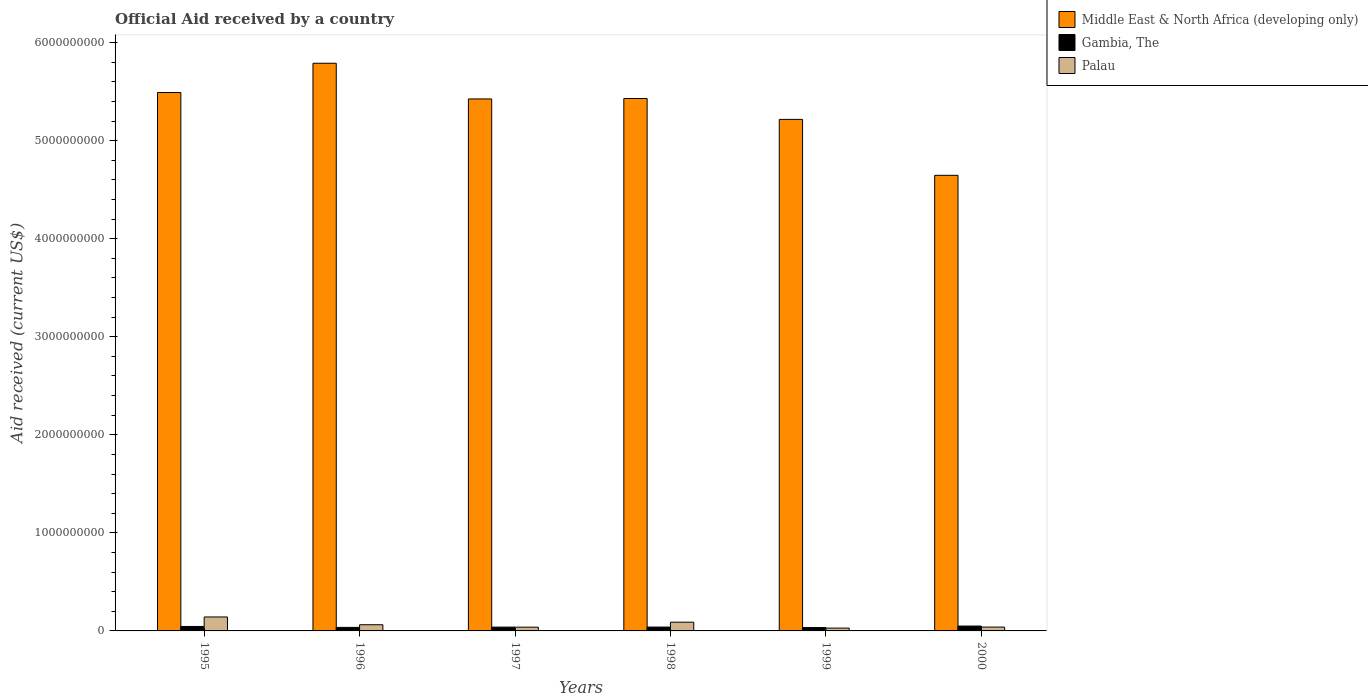Are the number of bars per tick equal to the number of legend labels?
Keep it short and to the point. Yes. What is the net official aid received in Gambia, The in 1997?
Provide a succinct answer. 3.88e+07. Across all years, what is the maximum net official aid received in Palau?
Provide a succinct answer. 1.42e+08. Across all years, what is the minimum net official aid received in Middle East & North Africa (developing only)?
Offer a very short reply. 4.65e+09. In which year was the net official aid received in Palau minimum?
Offer a very short reply. 1999. What is the total net official aid received in Middle East & North Africa (developing only) in the graph?
Keep it short and to the point. 3.20e+1. What is the difference between the net official aid received in Palau in 1996 and that in 2000?
Keep it short and to the point. 2.39e+07. What is the difference between the net official aid received in Palau in 1997 and the net official aid received in Gambia, The in 1995?
Ensure brevity in your answer.  -7.05e+06. What is the average net official aid received in Middle East & North Africa (developing only) per year?
Ensure brevity in your answer.  5.33e+09. In the year 1999, what is the difference between the net official aid received in Palau and net official aid received in Middle East & North Africa (developing only)?
Offer a terse response. -5.19e+09. What is the ratio of the net official aid received in Gambia, The in 1995 to that in 1998?
Your answer should be very brief. 1.16. Is the net official aid received in Palau in 1996 less than that in 1999?
Provide a short and direct response. No. What is the difference between the highest and the second highest net official aid received in Palau?
Make the answer very short. 5.32e+07. What is the difference between the highest and the lowest net official aid received in Gambia, The?
Keep it short and to the point. 1.54e+07. In how many years, is the net official aid received in Gambia, The greater than the average net official aid received in Gambia, The taken over all years?
Provide a succinct answer. 2. What does the 1st bar from the left in 1995 represents?
Offer a very short reply. Middle East & North Africa (developing only). What does the 1st bar from the right in 1998 represents?
Your answer should be very brief. Palau. How many bars are there?
Your answer should be very brief. 18. How many years are there in the graph?
Your answer should be very brief. 6. Are the values on the major ticks of Y-axis written in scientific E-notation?
Offer a very short reply. No. Does the graph contain any zero values?
Give a very brief answer. No. Does the graph contain grids?
Your response must be concise. No. Where does the legend appear in the graph?
Your response must be concise. Top right. How many legend labels are there?
Make the answer very short. 3. How are the legend labels stacked?
Keep it short and to the point. Vertical. What is the title of the graph?
Give a very brief answer. Official Aid received by a country. Does "Canada" appear as one of the legend labels in the graph?
Keep it short and to the point. No. What is the label or title of the X-axis?
Keep it short and to the point. Years. What is the label or title of the Y-axis?
Your answer should be compact. Aid received (current US$). What is the Aid received (current US$) of Middle East & North Africa (developing only) in 1995?
Offer a terse response. 5.49e+09. What is the Aid received (current US$) of Gambia, The in 1995?
Provide a short and direct response. 4.54e+07. What is the Aid received (current US$) in Palau in 1995?
Your answer should be very brief. 1.42e+08. What is the Aid received (current US$) of Middle East & North Africa (developing only) in 1996?
Your response must be concise. 5.79e+09. What is the Aid received (current US$) of Gambia, The in 1996?
Offer a very short reply. 3.61e+07. What is the Aid received (current US$) in Palau in 1996?
Keep it short and to the point. 6.30e+07. What is the Aid received (current US$) in Middle East & North Africa (developing only) in 1997?
Make the answer very short. 5.43e+09. What is the Aid received (current US$) of Gambia, The in 1997?
Provide a short and direct response. 3.88e+07. What is the Aid received (current US$) in Palau in 1997?
Provide a short and direct response. 3.84e+07. What is the Aid received (current US$) in Middle East & North Africa (developing only) in 1998?
Your response must be concise. 5.43e+09. What is the Aid received (current US$) of Gambia, The in 1998?
Your answer should be very brief. 3.93e+07. What is the Aid received (current US$) of Palau in 1998?
Offer a very short reply. 8.91e+07. What is the Aid received (current US$) in Middle East & North Africa (developing only) in 1999?
Keep it short and to the point. 5.22e+09. What is the Aid received (current US$) of Gambia, The in 1999?
Your answer should be very brief. 3.42e+07. What is the Aid received (current US$) of Palau in 1999?
Offer a terse response. 2.88e+07. What is the Aid received (current US$) in Middle East & North Africa (developing only) in 2000?
Provide a succinct answer. 4.65e+09. What is the Aid received (current US$) in Gambia, The in 2000?
Your answer should be compact. 4.96e+07. What is the Aid received (current US$) of Palau in 2000?
Provide a succinct answer. 3.91e+07. Across all years, what is the maximum Aid received (current US$) of Middle East & North Africa (developing only)?
Provide a succinct answer. 5.79e+09. Across all years, what is the maximum Aid received (current US$) of Gambia, The?
Your response must be concise. 4.96e+07. Across all years, what is the maximum Aid received (current US$) of Palau?
Offer a terse response. 1.42e+08. Across all years, what is the minimum Aid received (current US$) of Middle East & North Africa (developing only)?
Offer a terse response. 4.65e+09. Across all years, what is the minimum Aid received (current US$) of Gambia, The?
Provide a short and direct response. 3.42e+07. Across all years, what is the minimum Aid received (current US$) in Palau?
Offer a terse response. 2.88e+07. What is the total Aid received (current US$) in Middle East & North Africa (developing only) in the graph?
Offer a terse response. 3.20e+1. What is the total Aid received (current US$) of Gambia, The in the graph?
Offer a very short reply. 2.43e+08. What is the total Aid received (current US$) of Palau in the graph?
Ensure brevity in your answer.  4.01e+08. What is the difference between the Aid received (current US$) in Middle East & North Africa (developing only) in 1995 and that in 1996?
Make the answer very short. -2.99e+08. What is the difference between the Aid received (current US$) in Gambia, The in 1995 and that in 1996?
Offer a very short reply. 9.37e+06. What is the difference between the Aid received (current US$) in Palau in 1995 and that in 1996?
Keep it short and to the point. 7.93e+07. What is the difference between the Aid received (current US$) of Middle East & North Africa (developing only) in 1995 and that in 1997?
Ensure brevity in your answer.  6.53e+07. What is the difference between the Aid received (current US$) in Gambia, The in 1995 and that in 1997?
Provide a succinct answer. 6.66e+06. What is the difference between the Aid received (current US$) in Palau in 1995 and that in 1997?
Provide a succinct answer. 1.04e+08. What is the difference between the Aid received (current US$) of Middle East & North Africa (developing only) in 1995 and that in 1998?
Keep it short and to the point. 6.10e+07. What is the difference between the Aid received (current US$) in Gambia, The in 1995 and that in 1998?
Your answer should be compact. 6.11e+06. What is the difference between the Aid received (current US$) in Palau in 1995 and that in 1998?
Make the answer very short. 5.32e+07. What is the difference between the Aid received (current US$) in Middle East & North Africa (developing only) in 1995 and that in 1999?
Ensure brevity in your answer.  2.74e+08. What is the difference between the Aid received (current US$) of Gambia, The in 1995 and that in 1999?
Your answer should be very brief. 1.12e+07. What is the difference between the Aid received (current US$) of Palau in 1995 and that in 1999?
Give a very brief answer. 1.13e+08. What is the difference between the Aid received (current US$) in Middle East & North Africa (developing only) in 1995 and that in 2000?
Your response must be concise. 8.44e+08. What is the difference between the Aid received (current US$) in Gambia, The in 1995 and that in 2000?
Your response must be concise. -4.21e+06. What is the difference between the Aid received (current US$) of Palau in 1995 and that in 2000?
Give a very brief answer. 1.03e+08. What is the difference between the Aid received (current US$) of Middle East & North Africa (developing only) in 1996 and that in 1997?
Offer a terse response. 3.64e+08. What is the difference between the Aid received (current US$) in Gambia, The in 1996 and that in 1997?
Your answer should be compact. -2.71e+06. What is the difference between the Aid received (current US$) in Palau in 1996 and that in 1997?
Your response must be concise. 2.46e+07. What is the difference between the Aid received (current US$) in Middle East & North Africa (developing only) in 1996 and that in 1998?
Give a very brief answer. 3.60e+08. What is the difference between the Aid received (current US$) in Gambia, The in 1996 and that in 1998?
Your response must be concise. -3.26e+06. What is the difference between the Aid received (current US$) in Palau in 1996 and that in 1998?
Ensure brevity in your answer.  -2.61e+07. What is the difference between the Aid received (current US$) in Middle East & North Africa (developing only) in 1996 and that in 1999?
Offer a very short reply. 5.72e+08. What is the difference between the Aid received (current US$) of Gambia, The in 1996 and that in 1999?
Make the answer very short. 1.84e+06. What is the difference between the Aid received (current US$) of Palau in 1996 and that in 1999?
Make the answer very short. 3.42e+07. What is the difference between the Aid received (current US$) of Middle East & North Africa (developing only) in 1996 and that in 2000?
Make the answer very short. 1.14e+09. What is the difference between the Aid received (current US$) of Gambia, The in 1996 and that in 2000?
Ensure brevity in your answer.  -1.36e+07. What is the difference between the Aid received (current US$) of Palau in 1996 and that in 2000?
Provide a succinct answer. 2.39e+07. What is the difference between the Aid received (current US$) in Middle East & North Africa (developing only) in 1997 and that in 1998?
Make the answer very short. -4.32e+06. What is the difference between the Aid received (current US$) of Gambia, The in 1997 and that in 1998?
Provide a succinct answer. -5.50e+05. What is the difference between the Aid received (current US$) of Palau in 1997 and that in 1998?
Ensure brevity in your answer.  -5.07e+07. What is the difference between the Aid received (current US$) in Middle East & North Africa (developing only) in 1997 and that in 1999?
Provide a succinct answer. 2.08e+08. What is the difference between the Aid received (current US$) in Gambia, The in 1997 and that in 1999?
Offer a very short reply. 4.55e+06. What is the difference between the Aid received (current US$) in Palau in 1997 and that in 1999?
Your answer should be very brief. 9.54e+06. What is the difference between the Aid received (current US$) in Middle East & North Africa (developing only) in 1997 and that in 2000?
Provide a short and direct response. 7.79e+08. What is the difference between the Aid received (current US$) of Gambia, The in 1997 and that in 2000?
Your answer should be compact. -1.09e+07. What is the difference between the Aid received (current US$) in Palau in 1997 and that in 2000?
Give a very brief answer. -7.50e+05. What is the difference between the Aid received (current US$) of Middle East & North Africa (developing only) in 1998 and that in 1999?
Your answer should be very brief. 2.13e+08. What is the difference between the Aid received (current US$) in Gambia, The in 1998 and that in 1999?
Make the answer very short. 5.10e+06. What is the difference between the Aid received (current US$) in Palau in 1998 and that in 1999?
Your answer should be very brief. 6.03e+07. What is the difference between the Aid received (current US$) of Middle East & North Africa (developing only) in 1998 and that in 2000?
Give a very brief answer. 7.83e+08. What is the difference between the Aid received (current US$) of Gambia, The in 1998 and that in 2000?
Provide a short and direct response. -1.03e+07. What is the difference between the Aid received (current US$) in Palau in 1998 and that in 2000?
Provide a succinct answer. 5.00e+07. What is the difference between the Aid received (current US$) in Middle East & North Africa (developing only) in 1999 and that in 2000?
Give a very brief answer. 5.70e+08. What is the difference between the Aid received (current US$) of Gambia, The in 1999 and that in 2000?
Your answer should be very brief. -1.54e+07. What is the difference between the Aid received (current US$) of Palau in 1999 and that in 2000?
Offer a terse response. -1.03e+07. What is the difference between the Aid received (current US$) in Middle East & North Africa (developing only) in 1995 and the Aid received (current US$) in Gambia, The in 1996?
Keep it short and to the point. 5.45e+09. What is the difference between the Aid received (current US$) of Middle East & North Africa (developing only) in 1995 and the Aid received (current US$) of Palau in 1996?
Give a very brief answer. 5.43e+09. What is the difference between the Aid received (current US$) of Gambia, The in 1995 and the Aid received (current US$) of Palau in 1996?
Make the answer very short. -1.76e+07. What is the difference between the Aid received (current US$) in Middle East & North Africa (developing only) in 1995 and the Aid received (current US$) in Gambia, The in 1997?
Offer a terse response. 5.45e+09. What is the difference between the Aid received (current US$) in Middle East & North Africa (developing only) in 1995 and the Aid received (current US$) in Palau in 1997?
Offer a very short reply. 5.45e+09. What is the difference between the Aid received (current US$) of Gambia, The in 1995 and the Aid received (current US$) of Palau in 1997?
Your answer should be very brief. 7.05e+06. What is the difference between the Aid received (current US$) of Middle East & North Africa (developing only) in 1995 and the Aid received (current US$) of Gambia, The in 1998?
Offer a very short reply. 5.45e+09. What is the difference between the Aid received (current US$) in Middle East & North Africa (developing only) in 1995 and the Aid received (current US$) in Palau in 1998?
Ensure brevity in your answer.  5.40e+09. What is the difference between the Aid received (current US$) in Gambia, The in 1995 and the Aid received (current US$) in Palau in 1998?
Give a very brief answer. -4.37e+07. What is the difference between the Aid received (current US$) in Middle East & North Africa (developing only) in 1995 and the Aid received (current US$) in Gambia, The in 1999?
Provide a succinct answer. 5.46e+09. What is the difference between the Aid received (current US$) in Middle East & North Africa (developing only) in 1995 and the Aid received (current US$) in Palau in 1999?
Keep it short and to the point. 5.46e+09. What is the difference between the Aid received (current US$) of Gambia, The in 1995 and the Aid received (current US$) of Palau in 1999?
Keep it short and to the point. 1.66e+07. What is the difference between the Aid received (current US$) of Middle East & North Africa (developing only) in 1995 and the Aid received (current US$) of Gambia, The in 2000?
Give a very brief answer. 5.44e+09. What is the difference between the Aid received (current US$) of Middle East & North Africa (developing only) in 1995 and the Aid received (current US$) of Palau in 2000?
Offer a very short reply. 5.45e+09. What is the difference between the Aid received (current US$) in Gambia, The in 1995 and the Aid received (current US$) in Palau in 2000?
Give a very brief answer. 6.30e+06. What is the difference between the Aid received (current US$) in Middle East & North Africa (developing only) in 1996 and the Aid received (current US$) in Gambia, The in 1997?
Your answer should be compact. 5.75e+09. What is the difference between the Aid received (current US$) in Middle East & North Africa (developing only) in 1996 and the Aid received (current US$) in Palau in 1997?
Keep it short and to the point. 5.75e+09. What is the difference between the Aid received (current US$) of Gambia, The in 1996 and the Aid received (current US$) of Palau in 1997?
Make the answer very short. -2.32e+06. What is the difference between the Aid received (current US$) of Middle East & North Africa (developing only) in 1996 and the Aid received (current US$) of Gambia, The in 1998?
Make the answer very short. 5.75e+09. What is the difference between the Aid received (current US$) of Middle East & North Africa (developing only) in 1996 and the Aid received (current US$) of Palau in 1998?
Your response must be concise. 5.70e+09. What is the difference between the Aid received (current US$) of Gambia, The in 1996 and the Aid received (current US$) of Palau in 1998?
Ensure brevity in your answer.  -5.31e+07. What is the difference between the Aid received (current US$) of Middle East & North Africa (developing only) in 1996 and the Aid received (current US$) of Gambia, The in 1999?
Your answer should be compact. 5.76e+09. What is the difference between the Aid received (current US$) in Middle East & North Africa (developing only) in 1996 and the Aid received (current US$) in Palau in 1999?
Offer a terse response. 5.76e+09. What is the difference between the Aid received (current US$) in Gambia, The in 1996 and the Aid received (current US$) in Palau in 1999?
Offer a very short reply. 7.22e+06. What is the difference between the Aid received (current US$) of Middle East & North Africa (developing only) in 1996 and the Aid received (current US$) of Gambia, The in 2000?
Your response must be concise. 5.74e+09. What is the difference between the Aid received (current US$) of Middle East & North Africa (developing only) in 1996 and the Aid received (current US$) of Palau in 2000?
Keep it short and to the point. 5.75e+09. What is the difference between the Aid received (current US$) in Gambia, The in 1996 and the Aid received (current US$) in Palau in 2000?
Keep it short and to the point. -3.07e+06. What is the difference between the Aid received (current US$) in Middle East & North Africa (developing only) in 1997 and the Aid received (current US$) in Gambia, The in 1998?
Offer a terse response. 5.39e+09. What is the difference between the Aid received (current US$) of Middle East & North Africa (developing only) in 1997 and the Aid received (current US$) of Palau in 1998?
Your answer should be compact. 5.34e+09. What is the difference between the Aid received (current US$) of Gambia, The in 1997 and the Aid received (current US$) of Palau in 1998?
Provide a succinct answer. -5.04e+07. What is the difference between the Aid received (current US$) in Middle East & North Africa (developing only) in 1997 and the Aid received (current US$) in Gambia, The in 1999?
Ensure brevity in your answer.  5.39e+09. What is the difference between the Aid received (current US$) of Middle East & North Africa (developing only) in 1997 and the Aid received (current US$) of Palau in 1999?
Offer a very short reply. 5.40e+09. What is the difference between the Aid received (current US$) in Gambia, The in 1997 and the Aid received (current US$) in Palau in 1999?
Provide a succinct answer. 9.93e+06. What is the difference between the Aid received (current US$) in Middle East & North Africa (developing only) in 1997 and the Aid received (current US$) in Gambia, The in 2000?
Ensure brevity in your answer.  5.38e+09. What is the difference between the Aid received (current US$) in Middle East & North Africa (developing only) in 1997 and the Aid received (current US$) in Palau in 2000?
Make the answer very short. 5.39e+09. What is the difference between the Aid received (current US$) of Gambia, The in 1997 and the Aid received (current US$) of Palau in 2000?
Your answer should be compact. -3.60e+05. What is the difference between the Aid received (current US$) of Middle East & North Africa (developing only) in 1998 and the Aid received (current US$) of Gambia, The in 1999?
Give a very brief answer. 5.40e+09. What is the difference between the Aid received (current US$) of Middle East & North Africa (developing only) in 1998 and the Aid received (current US$) of Palau in 1999?
Your response must be concise. 5.40e+09. What is the difference between the Aid received (current US$) of Gambia, The in 1998 and the Aid received (current US$) of Palau in 1999?
Make the answer very short. 1.05e+07. What is the difference between the Aid received (current US$) in Middle East & North Africa (developing only) in 1998 and the Aid received (current US$) in Gambia, The in 2000?
Your answer should be compact. 5.38e+09. What is the difference between the Aid received (current US$) of Middle East & North Africa (developing only) in 1998 and the Aid received (current US$) of Palau in 2000?
Provide a succinct answer. 5.39e+09. What is the difference between the Aid received (current US$) of Gambia, The in 1998 and the Aid received (current US$) of Palau in 2000?
Provide a short and direct response. 1.90e+05. What is the difference between the Aid received (current US$) in Middle East & North Africa (developing only) in 1999 and the Aid received (current US$) in Gambia, The in 2000?
Keep it short and to the point. 5.17e+09. What is the difference between the Aid received (current US$) in Middle East & North Africa (developing only) in 1999 and the Aid received (current US$) in Palau in 2000?
Ensure brevity in your answer.  5.18e+09. What is the difference between the Aid received (current US$) of Gambia, The in 1999 and the Aid received (current US$) of Palau in 2000?
Your response must be concise. -4.91e+06. What is the average Aid received (current US$) in Middle East & North Africa (developing only) per year?
Your answer should be compact. 5.33e+09. What is the average Aid received (current US$) of Gambia, The per year?
Give a very brief answer. 4.06e+07. What is the average Aid received (current US$) in Palau per year?
Offer a very short reply. 6.68e+07. In the year 1995, what is the difference between the Aid received (current US$) in Middle East & North Africa (developing only) and Aid received (current US$) in Gambia, The?
Give a very brief answer. 5.45e+09. In the year 1995, what is the difference between the Aid received (current US$) of Middle East & North Africa (developing only) and Aid received (current US$) of Palau?
Give a very brief answer. 5.35e+09. In the year 1995, what is the difference between the Aid received (current US$) of Gambia, The and Aid received (current US$) of Palau?
Give a very brief answer. -9.69e+07. In the year 1996, what is the difference between the Aid received (current US$) in Middle East & North Africa (developing only) and Aid received (current US$) in Gambia, The?
Offer a terse response. 5.75e+09. In the year 1996, what is the difference between the Aid received (current US$) in Middle East & North Africa (developing only) and Aid received (current US$) in Palau?
Offer a terse response. 5.73e+09. In the year 1996, what is the difference between the Aid received (current US$) in Gambia, The and Aid received (current US$) in Palau?
Provide a succinct answer. -2.70e+07. In the year 1997, what is the difference between the Aid received (current US$) of Middle East & North Africa (developing only) and Aid received (current US$) of Gambia, The?
Your answer should be very brief. 5.39e+09. In the year 1997, what is the difference between the Aid received (current US$) of Middle East & North Africa (developing only) and Aid received (current US$) of Palau?
Give a very brief answer. 5.39e+09. In the year 1997, what is the difference between the Aid received (current US$) in Gambia, The and Aid received (current US$) in Palau?
Offer a very short reply. 3.90e+05. In the year 1998, what is the difference between the Aid received (current US$) in Middle East & North Africa (developing only) and Aid received (current US$) in Gambia, The?
Your response must be concise. 5.39e+09. In the year 1998, what is the difference between the Aid received (current US$) of Middle East & North Africa (developing only) and Aid received (current US$) of Palau?
Your answer should be compact. 5.34e+09. In the year 1998, what is the difference between the Aid received (current US$) of Gambia, The and Aid received (current US$) of Palau?
Keep it short and to the point. -4.98e+07. In the year 1999, what is the difference between the Aid received (current US$) in Middle East & North Africa (developing only) and Aid received (current US$) in Gambia, The?
Ensure brevity in your answer.  5.18e+09. In the year 1999, what is the difference between the Aid received (current US$) of Middle East & North Africa (developing only) and Aid received (current US$) of Palau?
Offer a very short reply. 5.19e+09. In the year 1999, what is the difference between the Aid received (current US$) of Gambia, The and Aid received (current US$) of Palau?
Offer a very short reply. 5.38e+06. In the year 2000, what is the difference between the Aid received (current US$) of Middle East & North Africa (developing only) and Aid received (current US$) of Gambia, The?
Offer a terse response. 4.60e+09. In the year 2000, what is the difference between the Aid received (current US$) in Middle East & North Africa (developing only) and Aid received (current US$) in Palau?
Offer a terse response. 4.61e+09. In the year 2000, what is the difference between the Aid received (current US$) in Gambia, The and Aid received (current US$) in Palau?
Provide a short and direct response. 1.05e+07. What is the ratio of the Aid received (current US$) in Middle East & North Africa (developing only) in 1995 to that in 1996?
Provide a succinct answer. 0.95. What is the ratio of the Aid received (current US$) in Gambia, The in 1995 to that in 1996?
Keep it short and to the point. 1.26. What is the ratio of the Aid received (current US$) in Palau in 1995 to that in 1996?
Keep it short and to the point. 2.26. What is the ratio of the Aid received (current US$) of Gambia, The in 1995 to that in 1997?
Ensure brevity in your answer.  1.17. What is the ratio of the Aid received (current US$) in Palau in 1995 to that in 1997?
Make the answer very short. 3.71. What is the ratio of the Aid received (current US$) in Middle East & North Africa (developing only) in 1995 to that in 1998?
Ensure brevity in your answer.  1.01. What is the ratio of the Aid received (current US$) in Gambia, The in 1995 to that in 1998?
Give a very brief answer. 1.16. What is the ratio of the Aid received (current US$) in Palau in 1995 to that in 1998?
Your answer should be very brief. 1.6. What is the ratio of the Aid received (current US$) in Middle East & North Africa (developing only) in 1995 to that in 1999?
Your answer should be very brief. 1.05. What is the ratio of the Aid received (current US$) of Gambia, The in 1995 to that in 1999?
Offer a terse response. 1.33. What is the ratio of the Aid received (current US$) in Palau in 1995 to that in 1999?
Offer a very short reply. 4.93. What is the ratio of the Aid received (current US$) in Middle East & North Africa (developing only) in 1995 to that in 2000?
Give a very brief answer. 1.18. What is the ratio of the Aid received (current US$) in Gambia, The in 1995 to that in 2000?
Offer a very short reply. 0.92. What is the ratio of the Aid received (current US$) of Palau in 1995 to that in 2000?
Provide a short and direct response. 3.64. What is the ratio of the Aid received (current US$) in Middle East & North Africa (developing only) in 1996 to that in 1997?
Give a very brief answer. 1.07. What is the ratio of the Aid received (current US$) of Gambia, The in 1996 to that in 1997?
Keep it short and to the point. 0.93. What is the ratio of the Aid received (current US$) in Palau in 1996 to that in 1997?
Give a very brief answer. 1.64. What is the ratio of the Aid received (current US$) in Middle East & North Africa (developing only) in 1996 to that in 1998?
Give a very brief answer. 1.07. What is the ratio of the Aid received (current US$) in Gambia, The in 1996 to that in 1998?
Provide a short and direct response. 0.92. What is the ratio of the Aid received (current US$) of Palau in 1996 to that in 1998?
Give a very brief answer. 0.71. What is the ratio of the Aid received (current US$) of Middle East & North Africa (developing only) in 1996 to that in 1999?
Provide a succinct answer. 1.11. What is the ratio of the Aid received (current US$) in Gambia, The in 1996 to that in 1999?
Your answer should be very brief. 1.05. What is the ratio of the Aid received (current US$) of Palau in 1996 to that in 1999?
Your answer should be compact. 2.19. What is the ratio of the Aid received (current US$) of Middle East & North Africa (developing only) in 1996 to that in 2000?
Keep it short and to the point. 1.25. What is the ratio of the Aid received (current US$) in Gambia, The in 1996 to that in 2000?
Offer a very short reply. 0.73. What is the ratio of the Aid received (current US$) in Palau in 1996 to that in 2000?
Keep it short and to the point. 1.61. What is the ratio of the Aid received (current US$) of Palau in 1997 to that in 1998?
Make the answer very short. 0.43. What is the ratio of the Aid received (current US$) in Middle East & North Africa (developing only) in 1997 to that in 1999?
Ensure brevity in your answer.  1.04. What is the ratio of the Aid received (current US$) of Gambia, The in 1997 to that in 1999?
Give a very brief answer. 1.13. What is the ratio of the Aid received (current US$) in Palau in 1997 to that in 1999?
Offer a terse response. 1.33. What is the ratio of the Aid received (current US$) in Middle East & North Africa (developing only) in 1997 to that in 2000?
Offer a terse response. 1.17. What is the ratio of the Aid received (current US$) in Gambia, The in 1997 to that in 2000?
Your answer should be compact. 0.78. What is the ratio of the Aid received (current US$) in Palau in 1997 to that in 2000?
Keep it short and to the point. 0.98. What is the ratio of the Aid received (current US$) of Middle East & North Africa (developing only) in 1998 to that in 1999?
Offer a very short reply. 1.04. What is the ratio of the Aid received (current US$) in Gambia, The in 1998 to that in 1999?
Give a very brief answer. 1.15. What is the ratio of the Aid received (current US$) in Palau in 1998 to that in 1999?
Your answer should be compact. 3.09. What is the ratio of the Aid received (current US$) of Middle East & North Africa (developing only) in 1998 to that in 2000?
Make the answer very short. 1.17. What is the ratio of the Aid received (current US$) of Gambia, The in 1998 to that in 2000?
Offer a terse response. 0.79. What is the ratio of the Aid received (current US$) in Palau in 1998 to that in 2000?
Your response must be concise. 2.28. What is the ratio of the Aid received (current US$) of Middle East & North Africa (developing only) in 1999 to that in 2000?
Ensure brevity in your answer.  1.12. What is the ratio of the Aid received (current US$) in Gambia, The in 1999 to that in 2000?
Offer a terse response. 0.69. What is the ratio of the Aid received (current US$) of Palau in 1999 to that in 2000?
Offer a very short reply. 0.74. What is the difference between the highest and the second highest Aid received (current US$) of Middle East & North Africa (developing only)?
Ensure brevity in your answer.  2.99e+08. What is the difference between the highest and the second highest Aid received (current US$) of Gambia, The?
Give a very brief answer. 4.21e+06. What is the difference between the highest and the second highest Aid received (current US$) in Palau?
Your answer should be very brief. 5.32e+07. What is the difference between the highest and the lowest Aid received (current US$) of Middle East & North Africa (developing only)?
Your answer should be compact. 1.14e+09. What is the difference between the highest and the lowest Aid received (current US$) of Gambia, The?
Provide a succinct answer. 1.54e+07. What is the difference between the highest and the lowest Aid received (current US$) in Palau?
Offer a very short reply. 1.13e+08. 